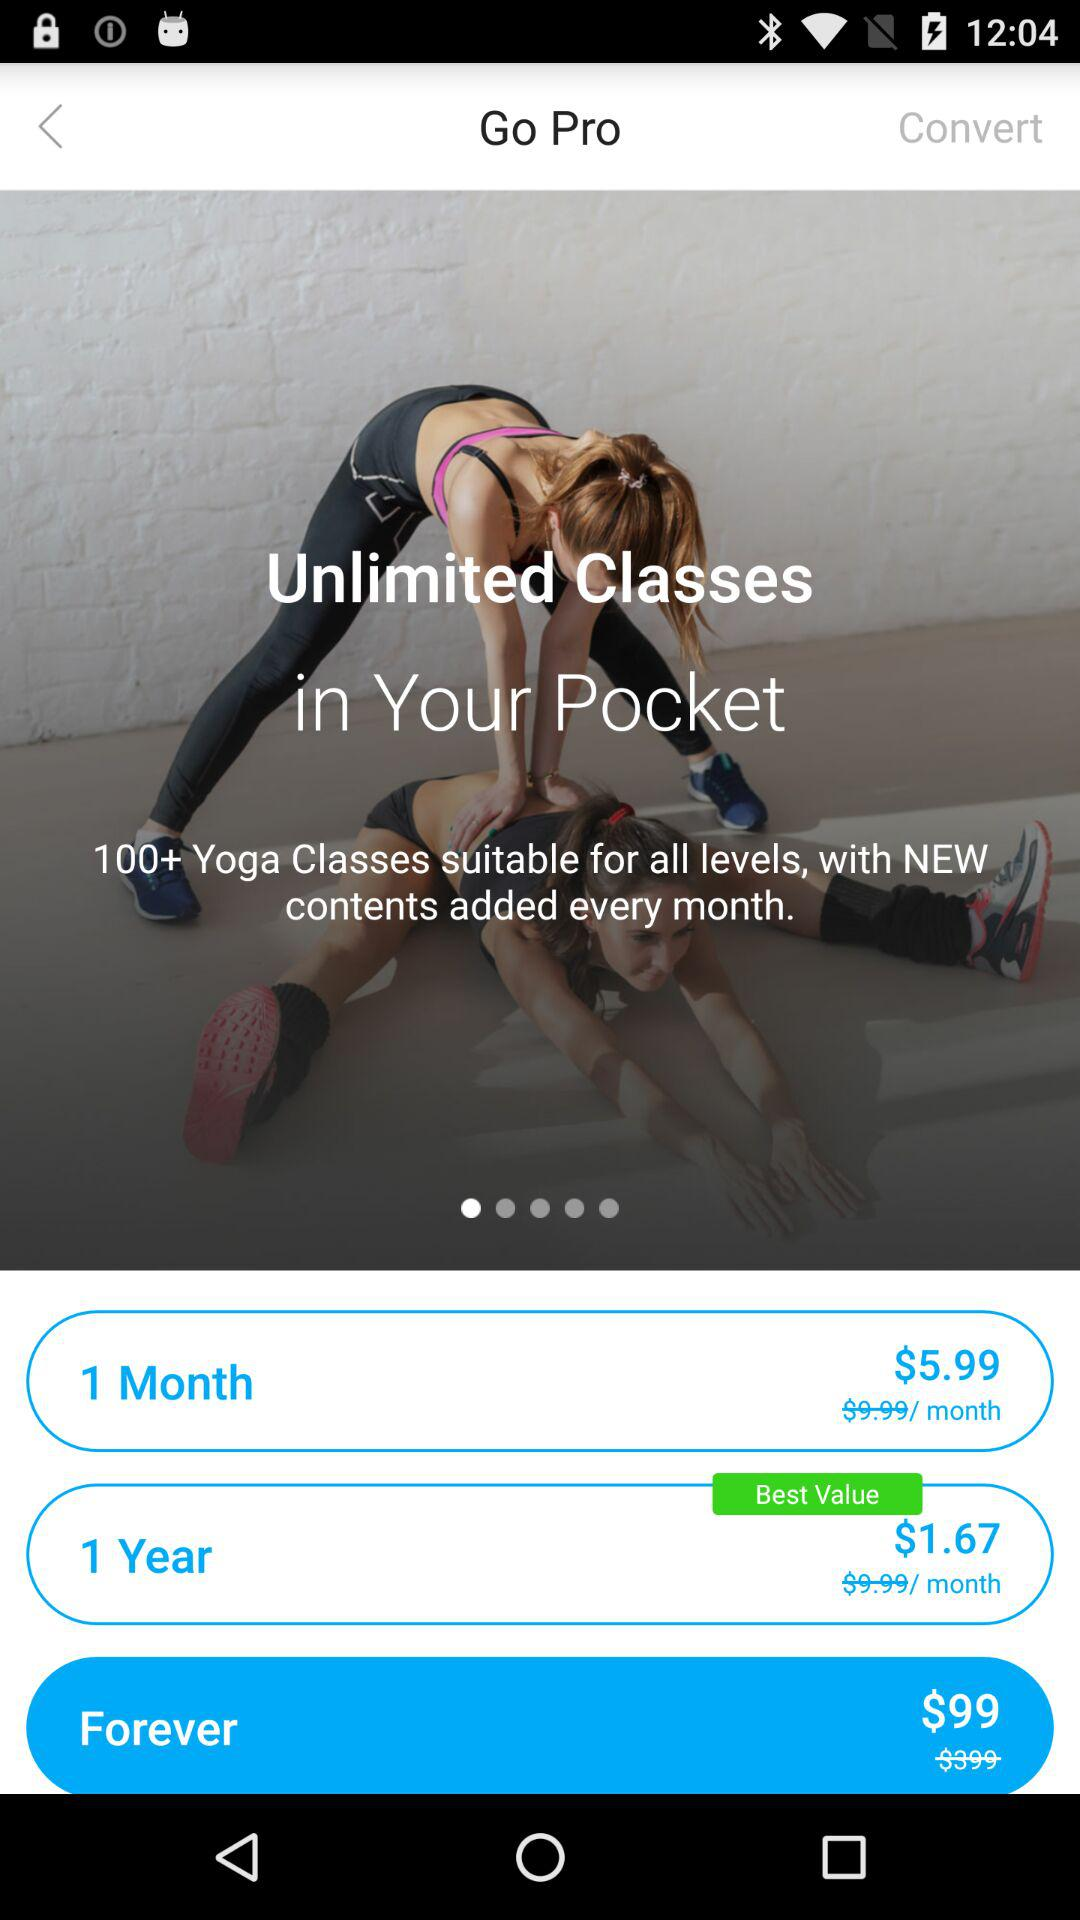How many yoga classes are available?
Answer the question using a single word or phrase. 100+ 